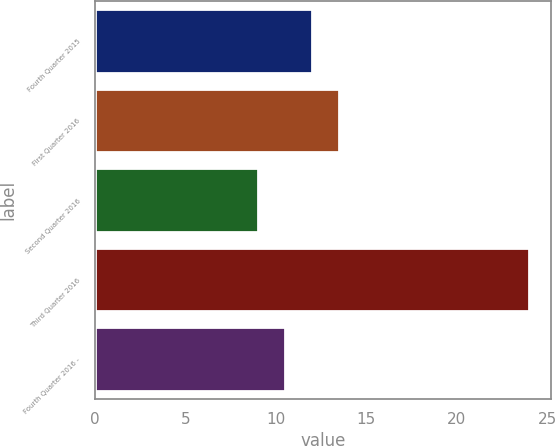Convert chart to OTSL. <chart><loc_0><loc_0><loc_500><loc_500><bar_chart><fcel>Fourth Quarter 2015<fcel>First Quarter 2016<fcel>Second Quarter 2016<fcel>Third Quarter 2016<fcel>Fourth Quarter 2016 -<nl><fcel>12<fcel>13.5<fcel>9<fcel>24<fcel>10.5<nl></chart> 